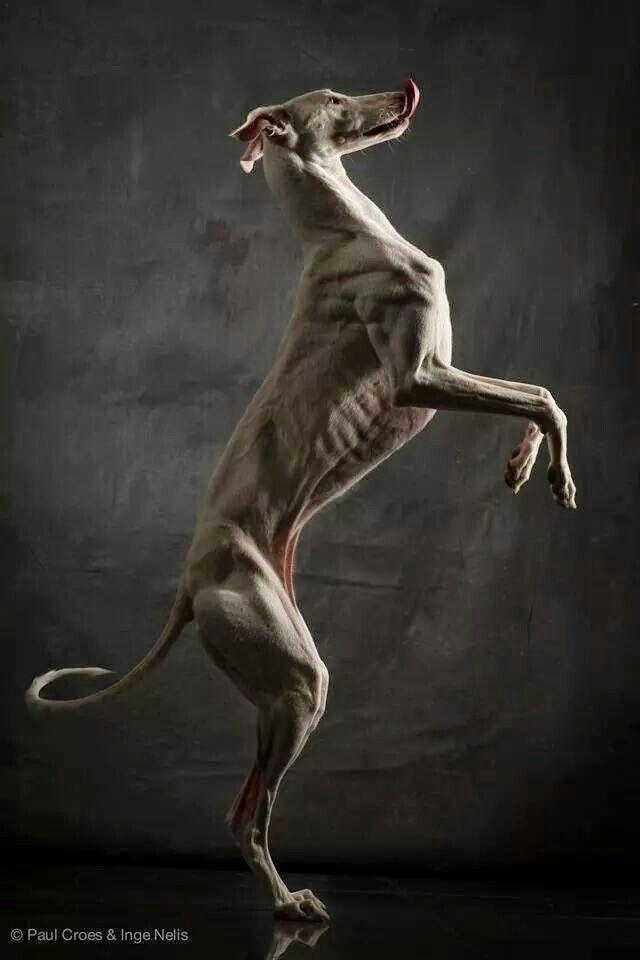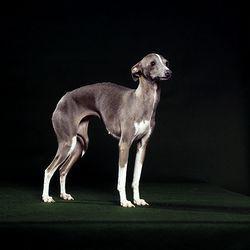The first image is the image on the left, the second image is the image on the right. Assess this claim about the two images: "A dog with a collar is looking at the camera in the image on the left.". Correct or not? Answer yes or no. No. The first image is the image on the left, the second image is the image on the right. For the images shown, is this caption "An image contains a thin dark dog that is looking towards the right." true? Answer yes or no. Yes. 